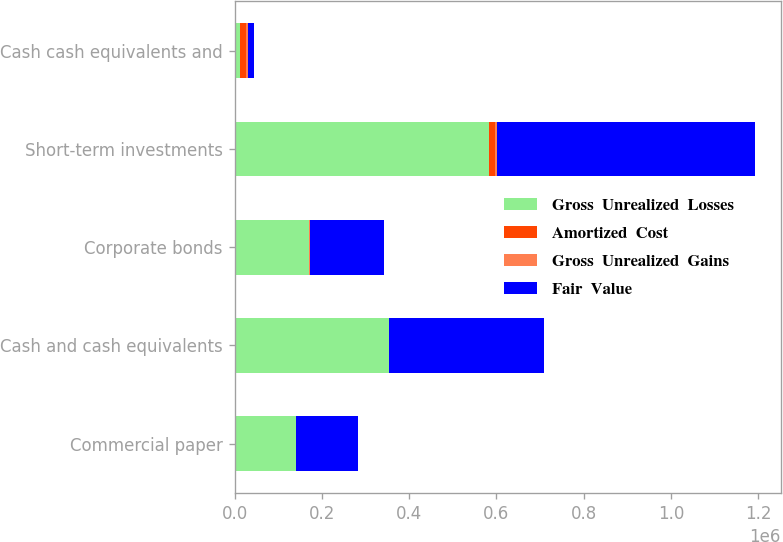Convert chart to OTSL. <chart><loc_0><loc_0><loc_500><loc_500><stacked_bar_chart><ecel><fcel>Commercial paper<fcel>Cash and cash equivalents<fcel>Corporate bonds<fcel>Short-term investments<fcel>Cash cash equivalents and<nl><fcel>Gross  Unrealized  Losses<fcel>141086<fcel>354485<fcel>171207<fcel>583119<fcel>12883<nl><fcel>Amortized  Cost<fcel>4<fcel>4<fcel>1<fcel>12881<fcel>12885<nl><fcel>Gross  Unrealized  Gains<fcel>155<fcel>158<fcel>1376<fcel>5371<fcel>5529<nl><fcel>Fair  Value<fcel>140935<fcel>354331<fcel>169832<fcel>590629<fcel>12883<nl></chart> 